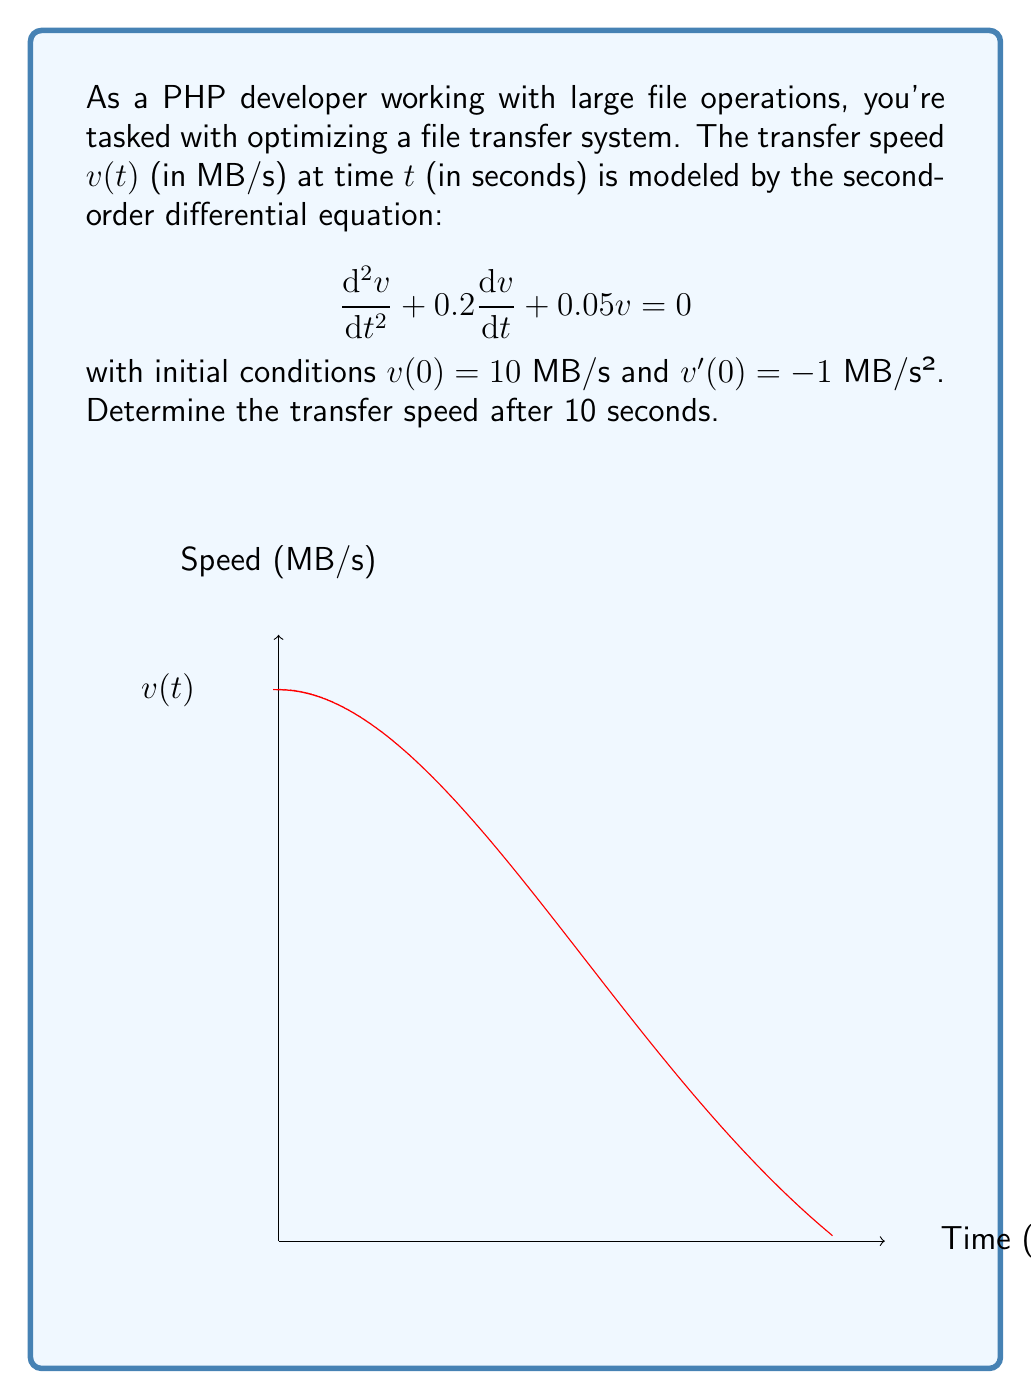Could you help me with this problem? Let's solve this step-by-step:

1) The characteristic equation for this differential equation is:
   $$r^2 + 0.2r + 0.05 = 0$$

2) Solving this quadratic equation:
   $$r = -0.1 \pm 0.2i$$

3) The general solution is therefore:
   $$v(t) = e^{-0.1t}(A\cos(0.2t) + B\sin(0.2t))$$

4) Using the initial condition $v(0) = 10$:
   $$10 = A$$

5) For $v'(0) = -1$, we differentiate $v(t)$:
   $$v'(t) = -0.1e^{-0.1t}(A\cos(0.2t) + B\sin(0.2t)) + e^{-0.1t}(-0.2A\sin(0.2t) + 0.2B\cos(0.2t))$$
   
   At $t=0$: $-1 = -0.1A + 0.2B$
   
   Substituting $A=10$: $-1 = -1 + 0.2B$
   
   Thus, $B = 5$

6) Our specific solution is:
   $$v(t) = 10e^{-0.1t}(\cos(0.2t) + 0.5\sin(0.2t))$$

7) Evaluating at $t=10$:
   $$v(10) = 10e^{-1}(\cos(2) + 0.5\sin(2))$$

8) Calculating this value:
   $$v(10) \approx 3.679 \text{ MB/s}$$
Answer: $3.679 \text{ MB/s}$ 